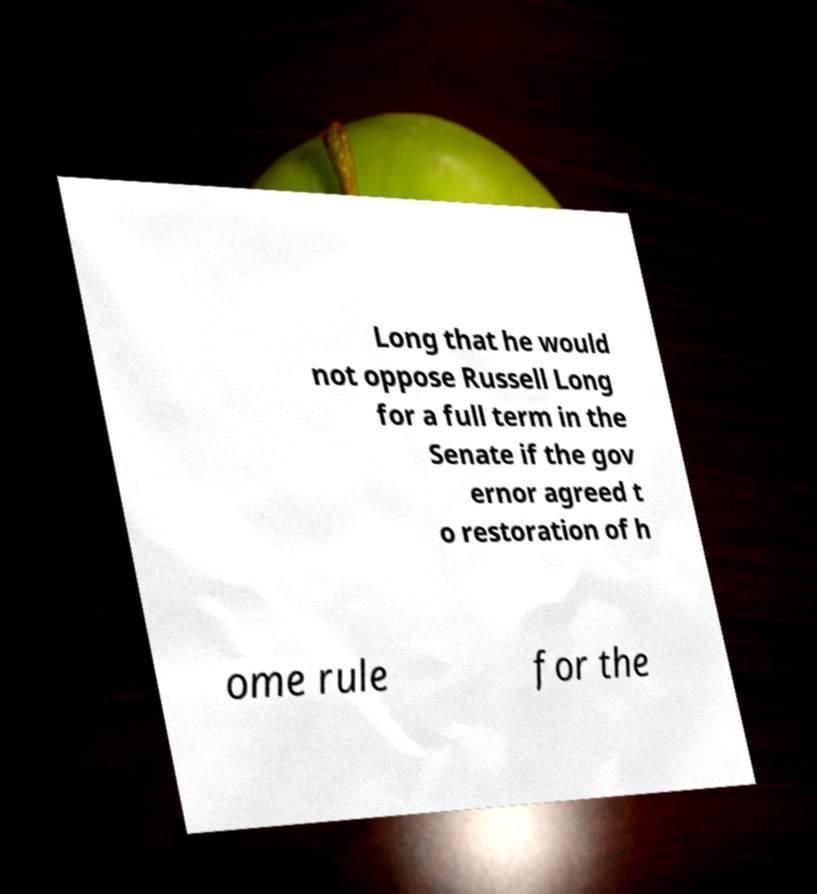Can you read and provide the text displayed in the image?This photo seems to have some interesting text. Can you extract and type it out for me? Long that he would not oppose Russell Long for a full term in the Senate if the gov ernor agreed t o restoration of h ome rule for the 